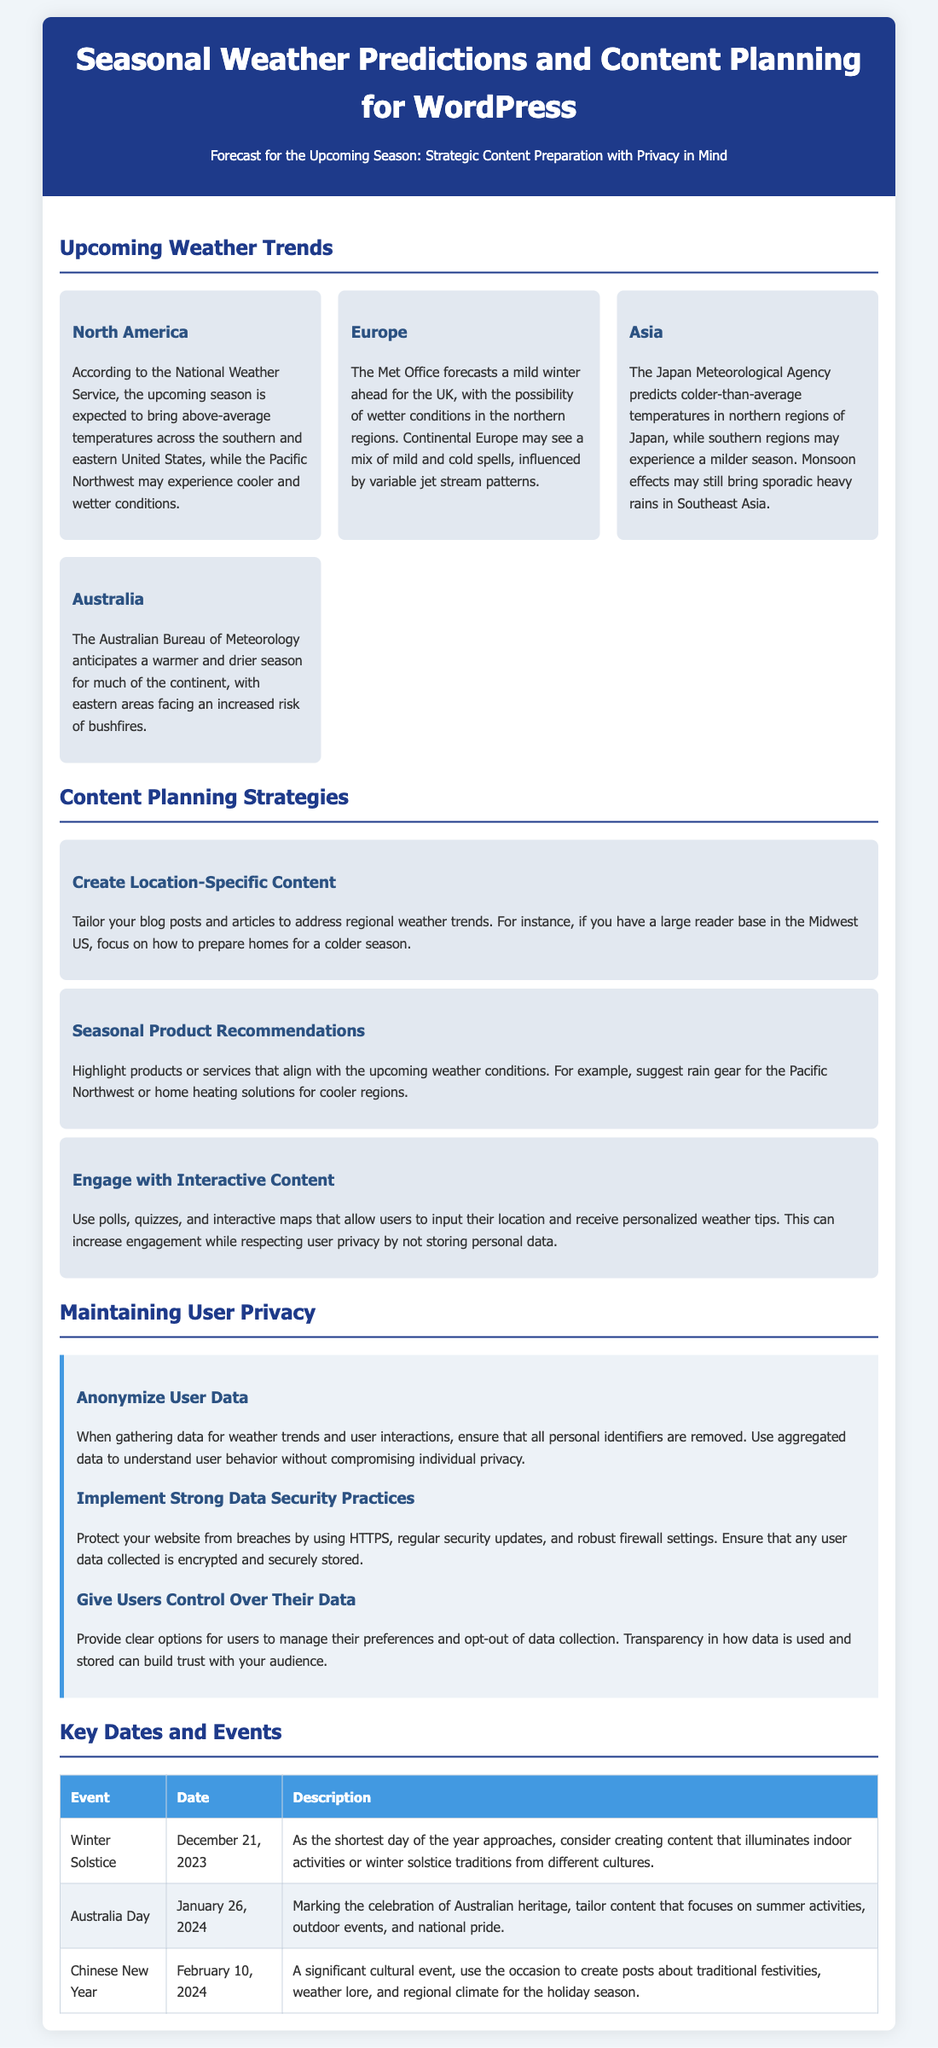What is the forecast for North America? The forecast mentions above-average temperatures across the southern and eastern United States, with cooler and wetter conditions in the Pacific Northwest.
Answer: Above-average temperatures across the southern and eastern United States, cooler and wetter in the Pacific Northwest What is the predicted temperature trend for northern Japan? The Japan Meteorological Agency's prediction indicates colder-than-average temperatures in northern regions of Japan.
Answer: Colder-than-average temperatures What is a suggested content strategy for the upcoming season? One effective strategy is to create location-specific content to address regional weather trends.
Answer: Create Location-Specific Content What is the date of the Winter Solstice? The document lists the date of the Winter Solstice as December 21, 2023.
Answer: December 21, 2023 What does the privacy tip "Anonymize User Data" recommend? The tip emphasizes removing personal identifiers when gathering data for weather trends and using aggregated data for insights.
Answer: Removing personal identifiers How might the upcoming weather influence content recommendations? Content recommendations could include seasonal products such as rain gear or home heating solutions depending on the weather conditions.
Answer: Seasonal Product Recommendations What cultural event is on February 10, 2024? The document states that February 10, 2024, is the date of the Chinese New Year.
Answer: Chinese New Year What type of content can be created for Australia Day? The document suggests tailoring content that focuses on summer activities and outdoor events for Australia Day.
Answer: Summer activities, outdoor events What is one data security practice mentioned in the document? One data security practice is to use HTTPS to protect websites from breaches.
Answer: Use HTTPS 